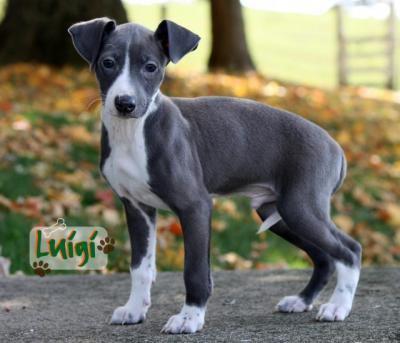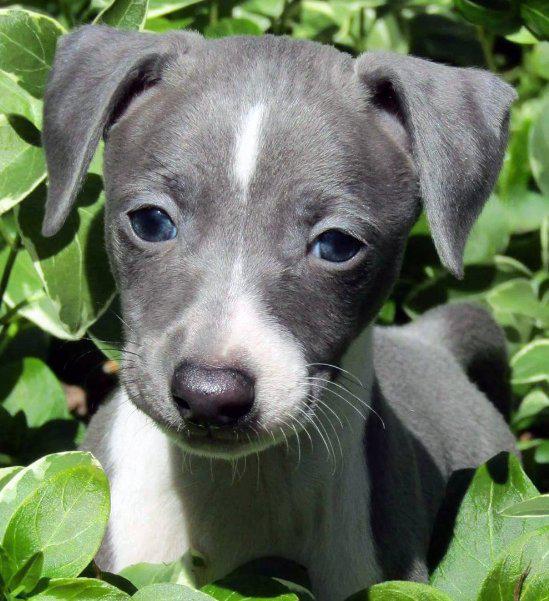The first image is the image on the left, the second image is the image on the right. Analyze the images presented: Is the assertion "The dog in one of the images is holding one paw up." valid? Answer yes or no. No. The first image is the image on the left, the second image is the image on the right. Given the left and right images, does the statement "At least one image in the pair contains a dog standing up with all four legs on the ground." hold true? Answer yes or no. Yes. 